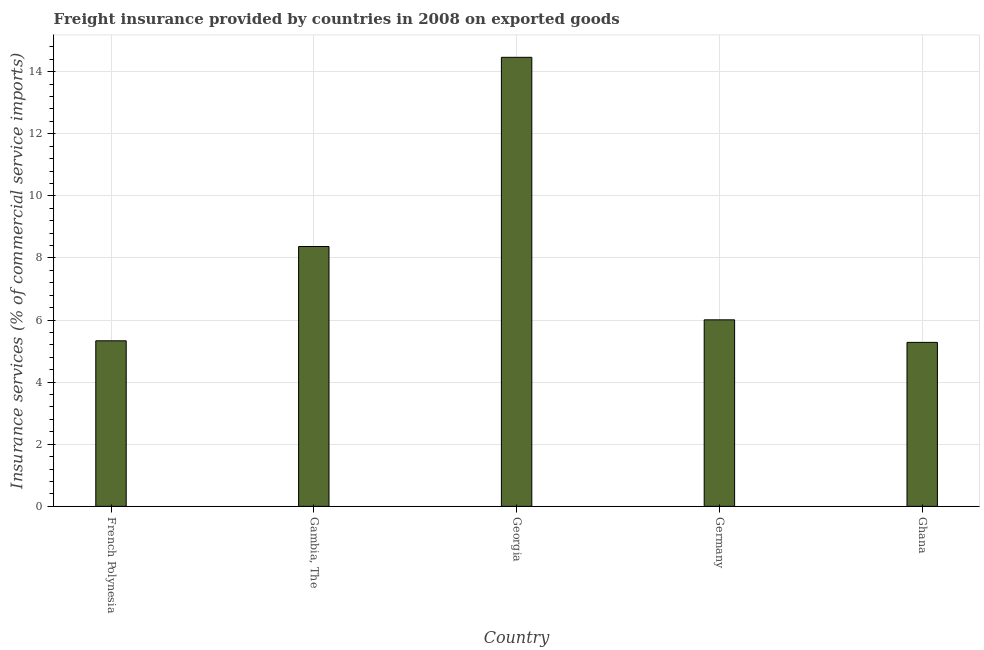Does the graph contain any zero values?
Your response must be concise. No. Does the graph contain grids?
Make the answer very short. Yes. What is the title of the graph?
Provide a short and direct response. Freight insurance provided by countries in 2008 on exported goods . What is the label or title of the Y-axis?
Ensure brevity in your answer.  Insurance services (% of commercial service imports). What is the freight insurance in Germany?
Offer a terse response. 6.01. Across all countries, what is the maximum freight insurance?
Make the answer very short. 14.46. Across all countries, what is the minimum freight insurance?
Offer a terse response. 5.28. In which country was the freight insurance maximum?
Give a very brief answer. Georgia. In which country was the freight insurance minimum?
Provide a short and direct response. Ghana. What is the sum of the freight insurance?
Provide a succinct answer. 39.45. What is the difference between the freight insurance in Gambia, The and Georgia?
Your response must be concise. -6.09. What is the average freight insurance per country?
Offer a very short reply. 7.89. What is the median freight insurance?
Give a very brief answer. 6.01. In how many countries, is the freight insurance greater than 11.6 %?
Offer a very short reply. 1. What is the ratio of the freight insurance in Gambia, The to that in Germany?
Make the answer very short. 1.39. Is the freight insurance in French Polynesia less than that in Germany?
Provide a succinct answer. Yes. Is the difference between the freight insurance in French Polynesia and Germany greater than the difference between any two countries?
Offer a terse response. No. What is the difference between the highest and the second highest freight insurance?
Provide a short and direct response. 6.09. What is the difference between the highest and the lowest freight insurance?
Your answer should be very brief. 9.18. In how many countries, is the freight insurance greater than the average freight insurance taken over all countries?
Your answer should be compact. 2. How many bars are there?
Offer a very short reply. 5. How many countries are there in the graph?
Provide a succinct answer. 5. What is the difference between two consecutive major ticks on the Y-axis?
Offer a very short reply. 2. What is the Insurance services (% of commercial service imports) of French Polynesia?
Your response must be concise. 5.33. What is the Insurance services (% of commercial service imports) in Gambia, The?
Your response must be concise. 8.37. What is the Insurance services (% of commercial service imports) of Georgia?
Give a very brief answer. 14.46. What is the Insurance services (% of commercial service imports) in Germany?
Ensure brevity in your answer.  6.01. What is the Insurance services (% of commercial service imports) of Ghana?
Your answer should be very brief. 5.28. What is the difference between the Insurance services (% of commercial service imports) in French Polynesia and Gambia, The?
Your answer should be compact. -3.04. What is the difference between the Insurance services (% of commercial service imports) in French Polynesia and Georgia?
Your answer should be compact. -9.13. What is the difference between the Insurance services (% of commercial service imports) in French Polynesia and Germany?
Offer a terse response. -0.68. What is the difference between the Insurance services (% of commercial service imports) in French Polynesia and Ghana?
Provide a succinct answer. 0.05. What is the difference between the Insurance services (% of commercial service imports) in Gambia, The and Georgia?
Your answer should be very brief. -6.09. What is the difference between the Insurance services (% of commercial service imports) in Gambia, The and Germany?
Provide a succinct answer. 2.36. What is the difference between the Insurance services (% of commercial service imports) in Gambia, The and Ghana?
Give a very brief answer. 3.09. What is the difference between the Insurance services (% of commercial service imports) in Georgia and Germany?
Keep it short and to the point. 8.46. What is the difference between the Insurance services (% of commercial service imports) in Georgia and Ghana?
Offer a very short reply. 9.18. What is the difference between the Insurance services (% of commercial service imports) in Germany and Ghana?
Keep it short and to the point. 0.73. What is the ratio of the Insurance services (% of commercial service imports) in French Polynesia to that in Gambia, The?
Offer a terse response. 0.64. What is the ratio of the Insurance services (% of commercial service imports) in French Polynesia to that in Georgia?
Your answer should be very brief. 0.37. What is the ratio of the Insurance services (% of commercial service imports) in French Polynesia to that in Germany?
Offer a terse response. 0.89. What is the ratio of the Insurance services (% of commercial service imports) in Gambia, The to that in Georgia?
Offer a terse response. 0.58. What is the ratio of the Insurance services (% of commercial service imports) in Gambia, The to that in Germany?
Give a very brief answer. 1.39. What is the ratio of the Insurance services (% of commercial service imports) in Gambia, The to that in Ghana?
Provide a succinct answer. 1.58. What is the ratio of the Insurance services (% of commercial service imports) in Georgia to that in Germany?
Your answer should be compact. 2.41. What is the ratio of the Insurance services (% of commercial service imports) in Georgia to that in Ghana?
Make the answer very short. 2.74. What is the ratio of the Insurance services (% of commercial service imports) in Germany to that in Ghana?
Make the answer very short. 1.14. 